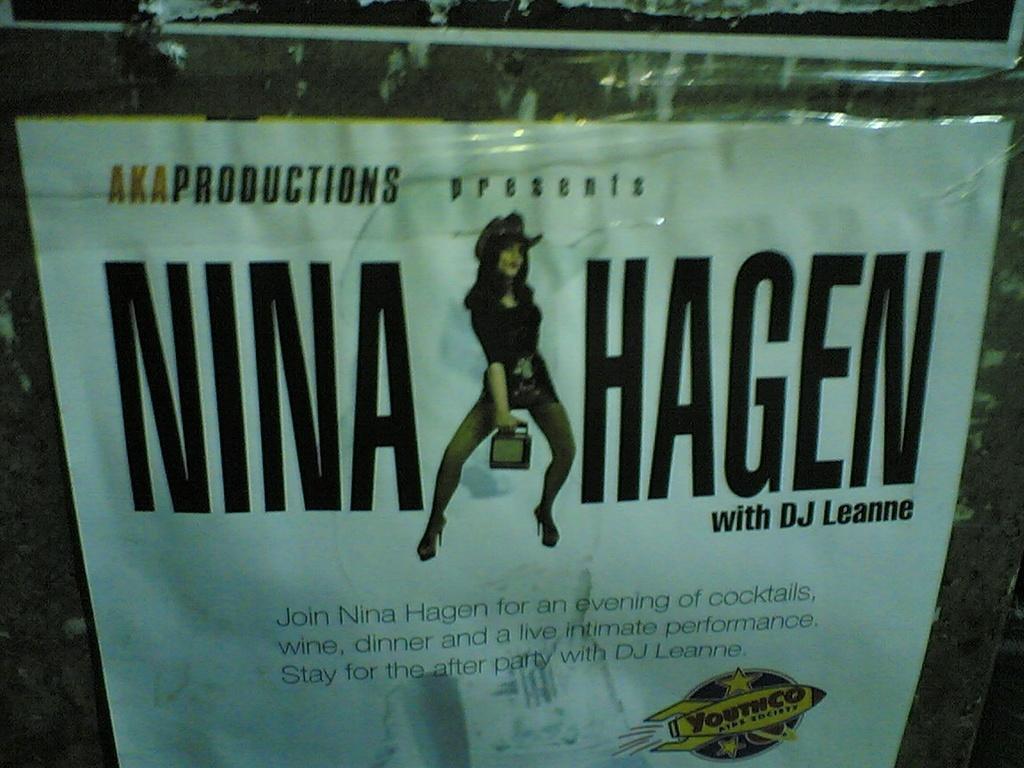Please provide a concise description of this image. In this image there is a poster. On the poster there is a picture of a lady and few texts are there. 